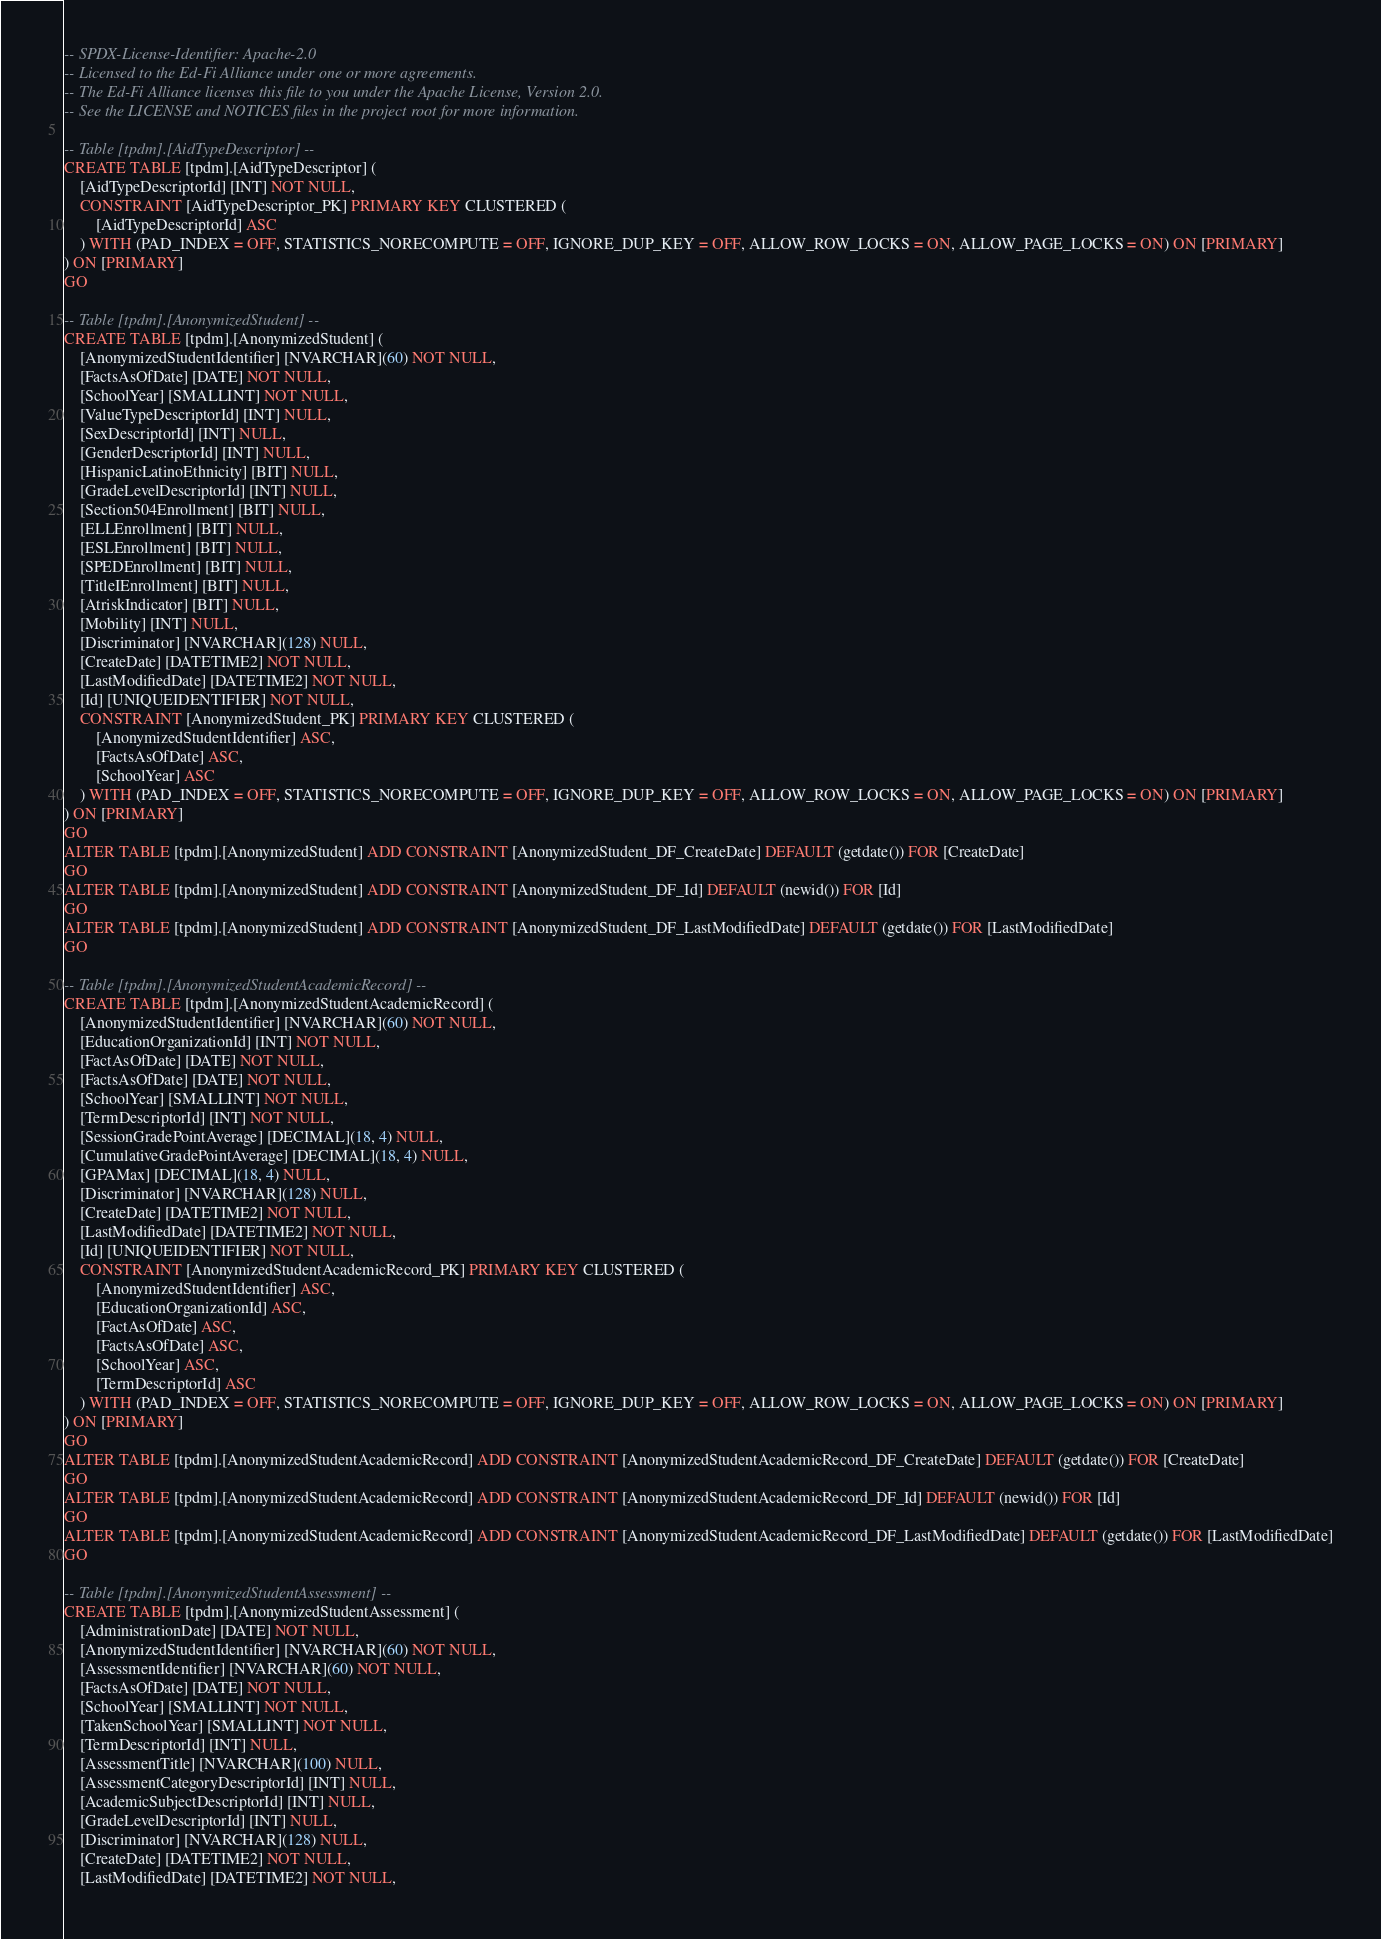<code> <loc_0><loc_0><loc_500><loc_500><_SQL_>-- SPDX-License-Identifier: Apache-2.0
-- Licensed to the Ed-Fi Alliance under one or more agreements.
-- The Ed-Fi Alliance licenses this file to you under the Apache License, Version 2.0.
-- See the LICENSE and NOTICES files in the project root for more information.

-- Table [tpdm].[AidTypeDescriptor] --
CREATE TABLE [tpdm].[AidTypeDescriptor] (
    [AidTypeDescriptorId] [INT] NOT NULL,
    CONSTRAINT [AidTypeDescriptor_PK] PRIMARY KEY CLUSTERED (
        [AidTypeDescriptorId] ASC
    ) WITH (PAD_INDEX = OFF, STATISTICS_NORECOMPUTE = OFF, IGNORE_DUP_KEY = OFF, ALLOW_ROW_LOCKS = ON, ALLOW_PAGE_LOCKS = ON) ON [PRIMARY]
) ON [PRIMARY]
GO

-- Table [tpdm].[AnonymizedStudent] --
CREATE TABLE [tpdm].[AnonymizedStudent] (
    [AnonymizedStudentIdentifier] [NVARCHAR](60) NOT NULL,
    [FactsAsOfDate] [DATE] NOT NULL,
    [SchoolYear] [SMALLINT] NOT NULL,
    [ValueTypeDescriptorId] [INT] NULL,
    [SexDescriptorId] [INT] NULL,
    [GenderDescriptorId] [INT] NULL,
    [HispanicLatinoEthnicity] [BIT] NULL,
    [GradeLevelDescriptorId] [INT] NULL,
    [Section504Enrollment] [BIT] NULL,
    [ELLEnrollment] [BIT] NULL,
    [ESLEnrollment] [BIT] NULL,
    [SPEDEnrollment] [BIT] NULL,
    [TitleIEnrollment] [BIT] NULL,
    [AtriskIndicator] [BIT] NULL,
    [Mobility] [INT] NULL,
    [Discriminator] [NVARCHAR](128) NULL,
    [CreateDate] [DATETIME2] NOT NULL,
    [LastModifiedDate] [DATETIME2] NOT NULL,
    [Id] [UNIQUEIDENTIFIER] NOT NULL,
    CONSTRAINT [AnonymizedStudent_PK] PRIMARY KEY CLUSTERED (
        [AnonymizedStudentIdentifier] ASC,
        [FactsAsOfDate] ASC,
        [SchoolYear] ASC
    ) WITH (PAD_INDEX = OFF, STATISTICS_NORECOMPUTE = OFF, IGNORE_DUP_KEY = OFF, ALLOW_ROW_LOCKS = ON, ALLOW_PAGE_LOCKS = ON) ON [PRIMARY]
) ON [PRIMARY]
GO
ALTER TABLE [tpdm].[AnonymizedStudent] ADD CONSTRAINT [AnonymizedStudent_DF_CreateDate] DEFAULT (getdate()) FOR [CreateDate]
GO
ALTER TABLE [tpdm].[AnonymizedStudent] ADD CONSTRAINT [AnonymizedStudent_DF_Id] DEFAULT (newid()) FOR [Id]
GO
ALTER TABLE [tpdm].[AnonymizedStudent] ADD CONSTRAINT [AnonymizedStudent_DF_LastModifiedDate] DEFAULT (getdate()) FOR [LastModifiedDate]
GO

-- Table [tpdm].[AnonymizedStudentAcademicRecord] --
CREATE TABLE [tpdm].[AnonymizedStudentAcademicRecord] (
    [AnonymizedStudentIdentifier] [NVARCHAR](60) NOT NULL,
    [EducationOrganizationId] [INT] NOT NULL,
    [FactAsOfDate] [DATE] NOT NULL,
    [FactsAsOfDate] [DATE] NOT NULL,
    [SchoolYear] [SMALLINT] NOT NULL,
    [TermDescriptorId] [INT] NOT NULL,
    [SessionGradePointAverage] [DECIMAL](18, 4) NULL,
    [CumulativeGradePointAverage] [DECIMAL](18, 4) NULL,
    [GPAMax] [DECIMAL](18, 4) NULL,
    [Discriminator] [NVARCHAR](128) NULL,
    [CreateDate] [DATETIME2] NOT NULL,
    [LastModifiedDate] [DATETIME2] NOT NULL,
    [Id] [UNIQUEIDENTIFIER] NOT NULL,
    CONSTRAINT [AnonymizedStudentAcademicRecord_PK] PRIMARY KEY CLUSTERED (
        [AnonymizedStudentIdentifier] ASC,
        [EducationOrganizationId] ASC,
        [FactAsOfDate] ASC,
        [FactsAsOfDate] ASC,
        [SchoolYear] ASC,
        [TermDescriptorId] ASC
    ) WITH (PAD_INDEX = OFF, STATISTICS_NORECOMPUTE = OFF, IGNORE_DUP_KEY = OFF, ALLOW_ROW_LOCKS = ON, ALLOW_PAGE_LOCKS = ON) ON [PRIMARY]
) ON [PRIMARY]
GO
ALTER TABLE [tpdm].[AnonymizedStudentAcademicRecord] ADD CONSTRAINT [AnonymizedStudentAcademicRecord_DF_CreateDate] DEFAULT (getdate()) FOR [CreateDate]
GO
ALTER TABLE [tpdm].[AnonymizedStudentAcademicRecord] ADD CONSTRAINT [AnonymizedStudentAcademicRecord_DF_Id] DEFAULT (newid()) FOR [Id]
GO
ALTER TABLE [tpdm].[AnonymizedStudentAcademicRecord] ADD CONSTRAINT [AnonymizedStudentAcademicRecord_DF_LastModifiedDate] DEFAULT (getdate()) FOR [LastModifiedDate]
GO

-- Table [tpdm].[AnonymizedStudentAssessment] --
CREATE TABLE [tpdm].[AnonymizedStudentAssessment] (
    [AdministrationDate] [DATE] NOT NULL,
    [AnonymizedStudentIdentifier] [NVARCHAR](60) NOT NULL,
    [AssessmentIdentifier] [NVARCHAR](60) NOT NULL,
    [FactsAsOfDate] [DATE] NOT NULL,
    [SchoolYear] [SMALLINT] NOT NULL,
    [TakenSchoolYear] [SMALLINT] NOT NULL,
    [TermDescriptorId] [INT] NULL,
    [AssessmentTitle] [NVARCHAR](100) NULL,
    [AssessmentCategoryDescriptorId] [INT] NULL,
    [AcademicSubjectDescriptorId] [INT] NULL,
    [GradeLevelDescriptorId] [INT] NULL,
    [Discriminator] [NVARCHAR](128) NULL,
    [CreateDate] [DATETIME2] NOT NULL,
    [LastModifiedDate] [DATETIME2] NOT NULL,</code> 